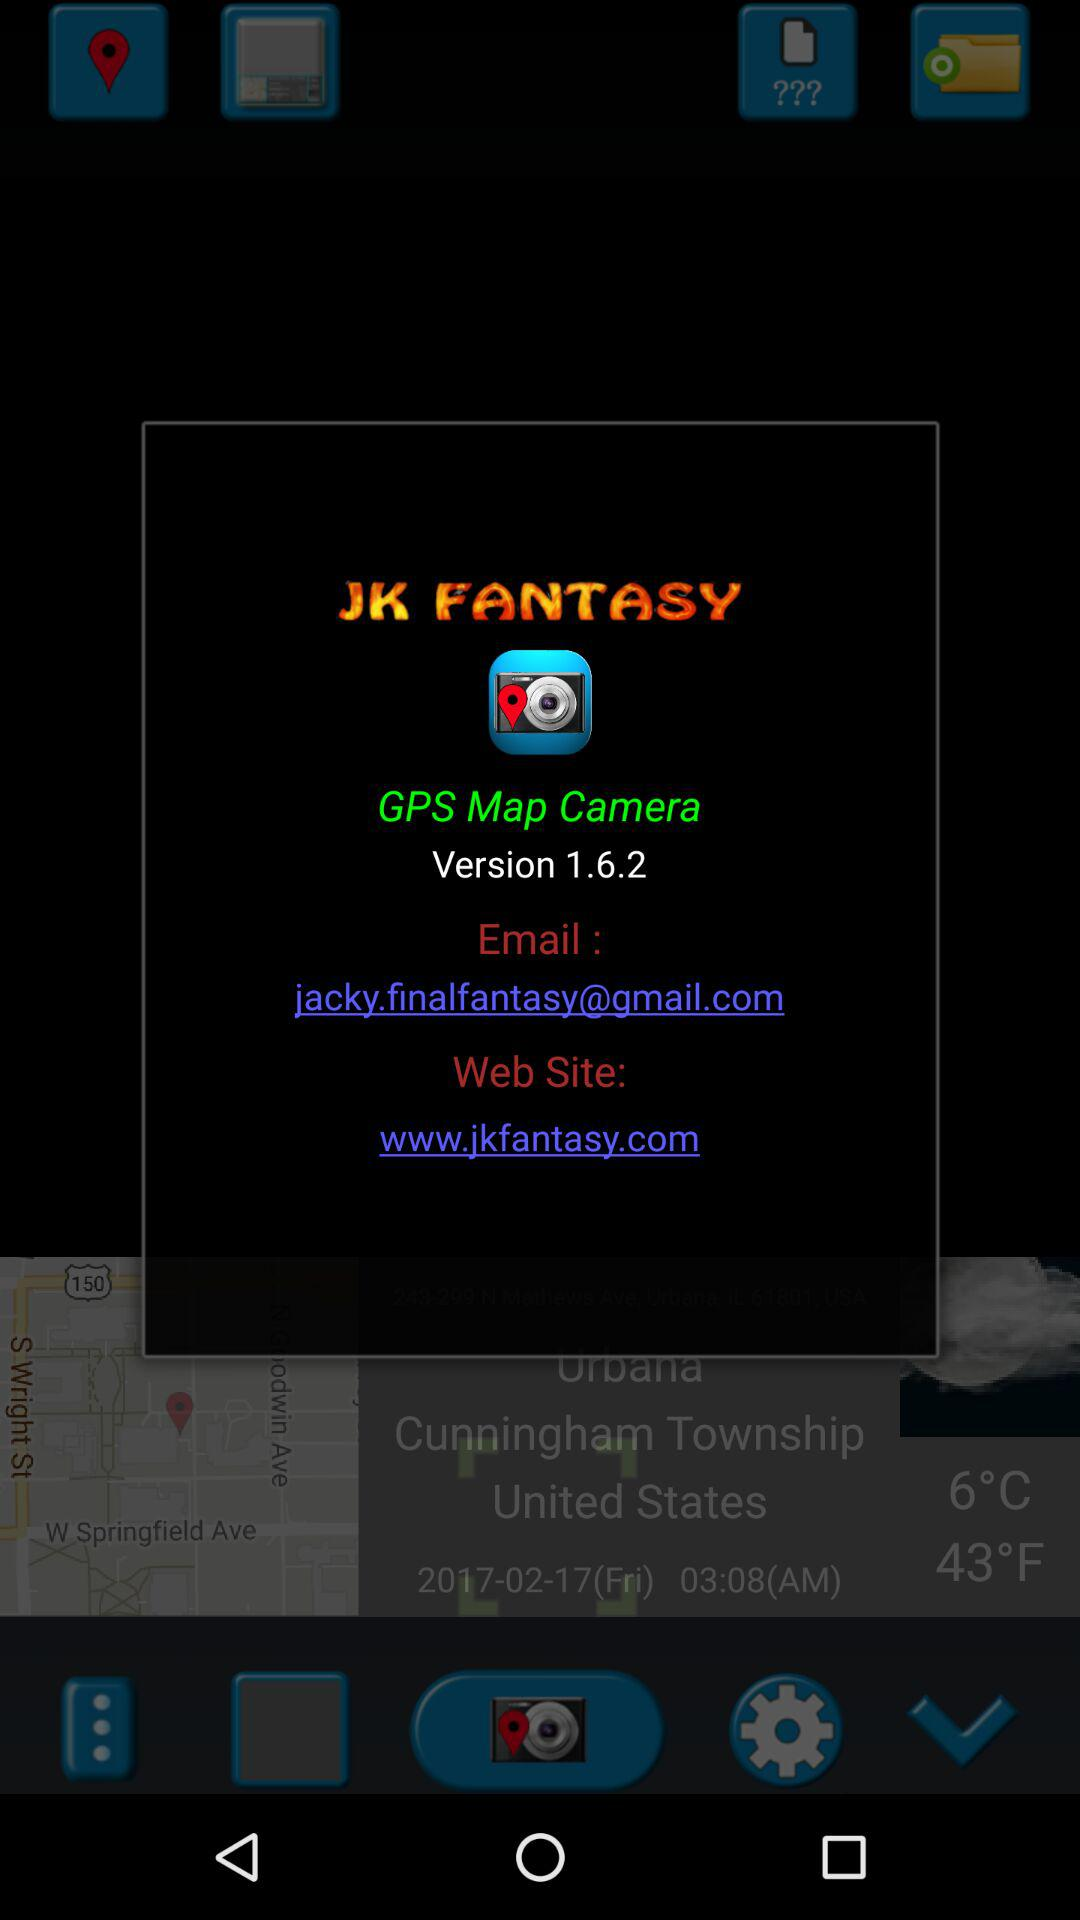Which version is used? The used version is 1.6.2. 